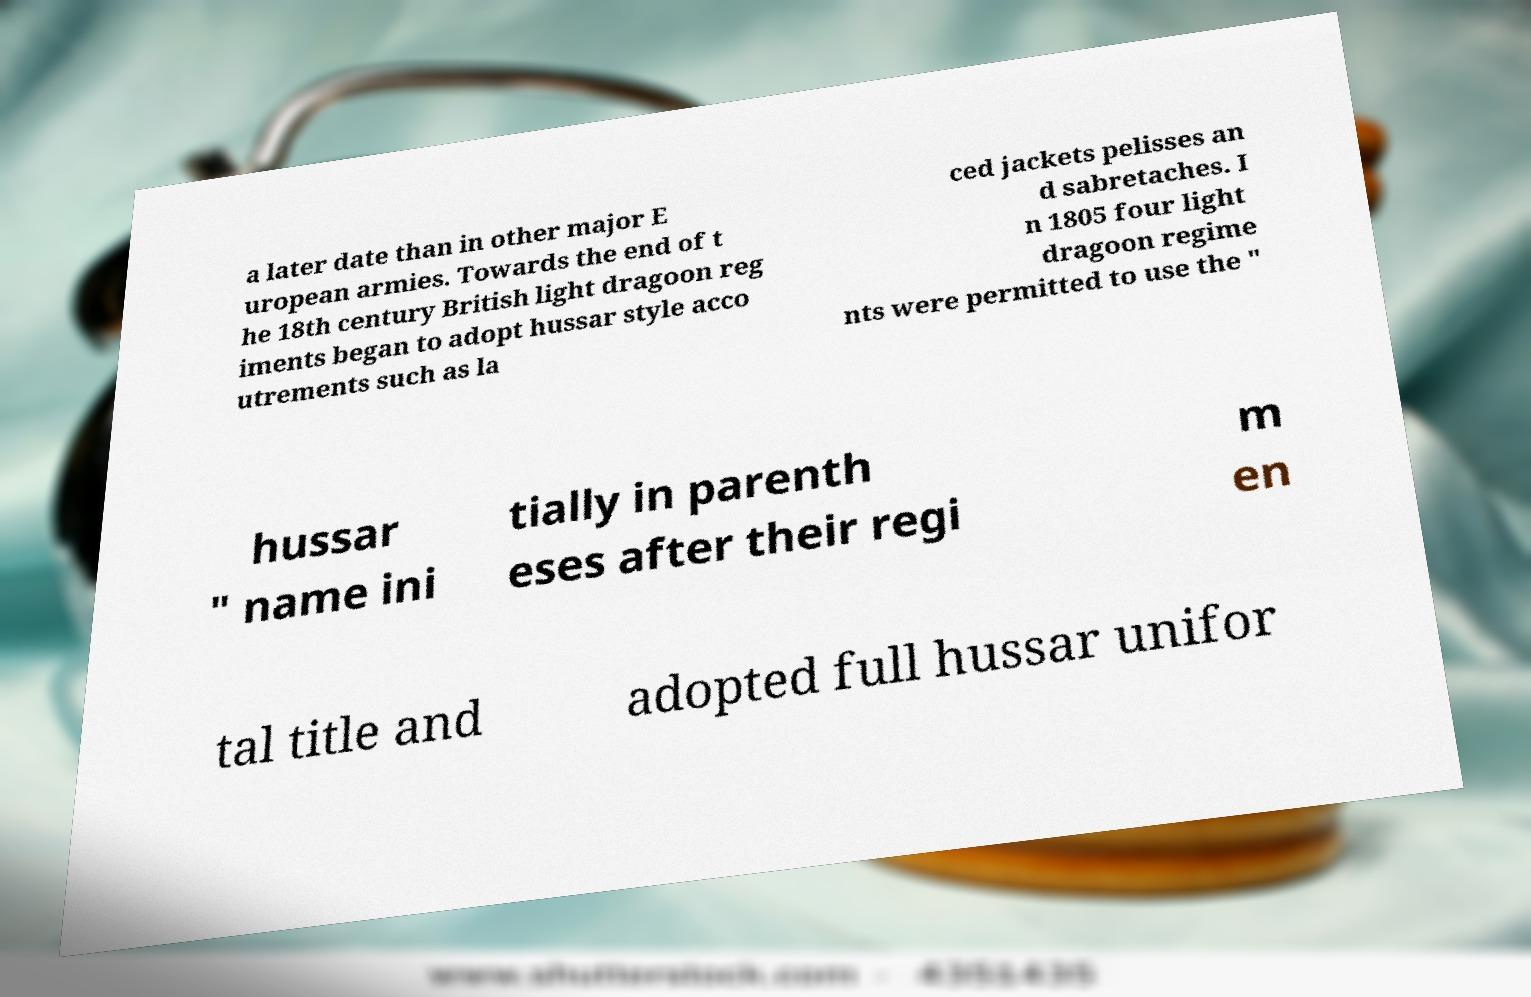There's text embedded in this image that I need extracted. Can you transcribe it verbatim? a later date than in other major E uropean armies. Towards the end of t he 18th century British light dragoon reg iments began to adopt hussar style acco utrements such as la ced jackets pelisses an d sabretaches. I n 1805 four light dragoon regime nts were permitted to use the " hussar " name ini tially in parenth eses after their regi m en tal title and adopted full hussar unifor 